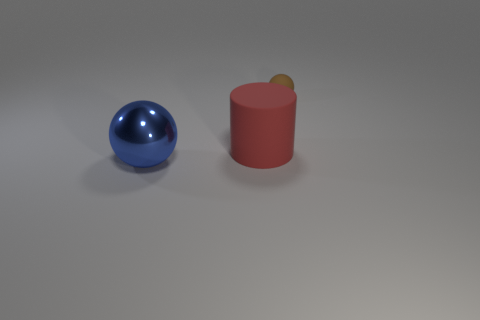Subtract all brown balls. How many balls are left? 1 Add 1 big red things. How many objects exist? 4 Subtract all cylinders. How many objects are left? 2 Add 3 large red things. How many large red things are left? 4 Add 3 spheres. How many spheres exist? 5 Subtract 0 cyan cubes. How many objects are left? 3 Subtract 1 spheres. How many spheres are left? 1 Subtract all green spheres. Subtract all yellow cylinders. How many spheres are left? 2 Subtract all gray cylinders. How many brown spheres are left? 1 Subtract all large gray things. Subtract all large matte cylinders. How many objects are left? 2 